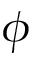<formula> <loc_0><loc_0><loc_500><loc_500>\phi</formula> 